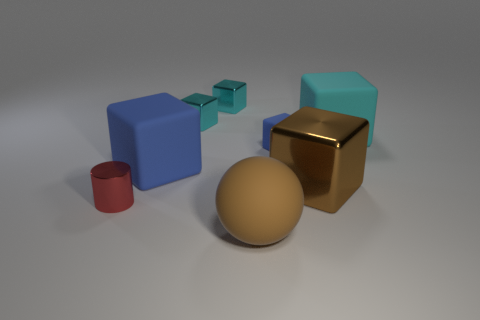How many cyan blocks must be subtracted to get 1 cyan blocks? 2 Subtract all green spheres. How many cyan blocks are left? 3 Subtract all blue cubes. How many cubes are left? 4 Subtract all cyan rubber cubes. How many cubes are left? 5 Subtract all green cubes. Subtract all purple balls. How many cubes are left? 6 Add 1 small blue cubes. How many objects exist? 9 Subtract all spheres. How many objects are left? 7 Subtract all big yellow rubber objects. Subtract all big blue rubber objects. How many objects are left? 7 Add 2 cyan matte objects. How many cyan matte objects are left? 3 Add 4 big cyan shiny blocks. How many big cyan shiny blocks exist? 4 